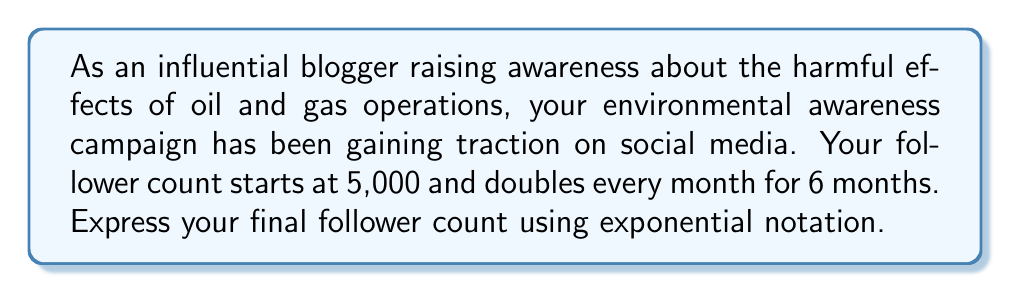Can you answer this question? Let's approach this step-by-step:

1) The initial number of followers is 5,000.

2) The growth factor is 2, as the number of followers doubles each month.

3) This doubling occurs for 6 months.

4) We can express this using the exponential growth formula:

   $A = P \cdot r^t$

   Where:
   $A$ = final amount
   $P$ = initial amount (principal)
   $r$ = growth factor
   $t$ = number of time periods

5) Plugging in our values:

   $A = 5000 \cdot 2^6$

6) This can be simplified as:

   $A = 5000 \cdot 64$

7) However, the question asks for the answer in exponential notation, so we'll leave it as:

   $A = 5000 \cdot 2^6$

This expression represents the final number of followers after 6 months of doubling.
Answer: $5000 \cdot 2^6$ followers 